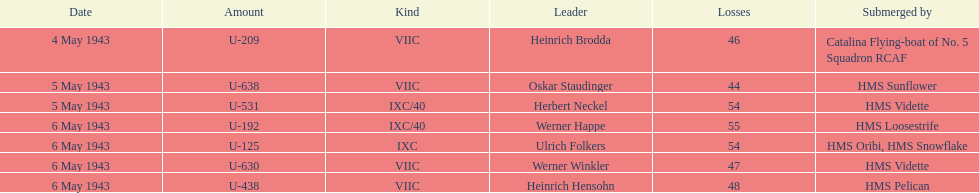Aside from oskar staudinger what was the name of the other captain of the u-boat loast on may 5? Herbert Neckel. 